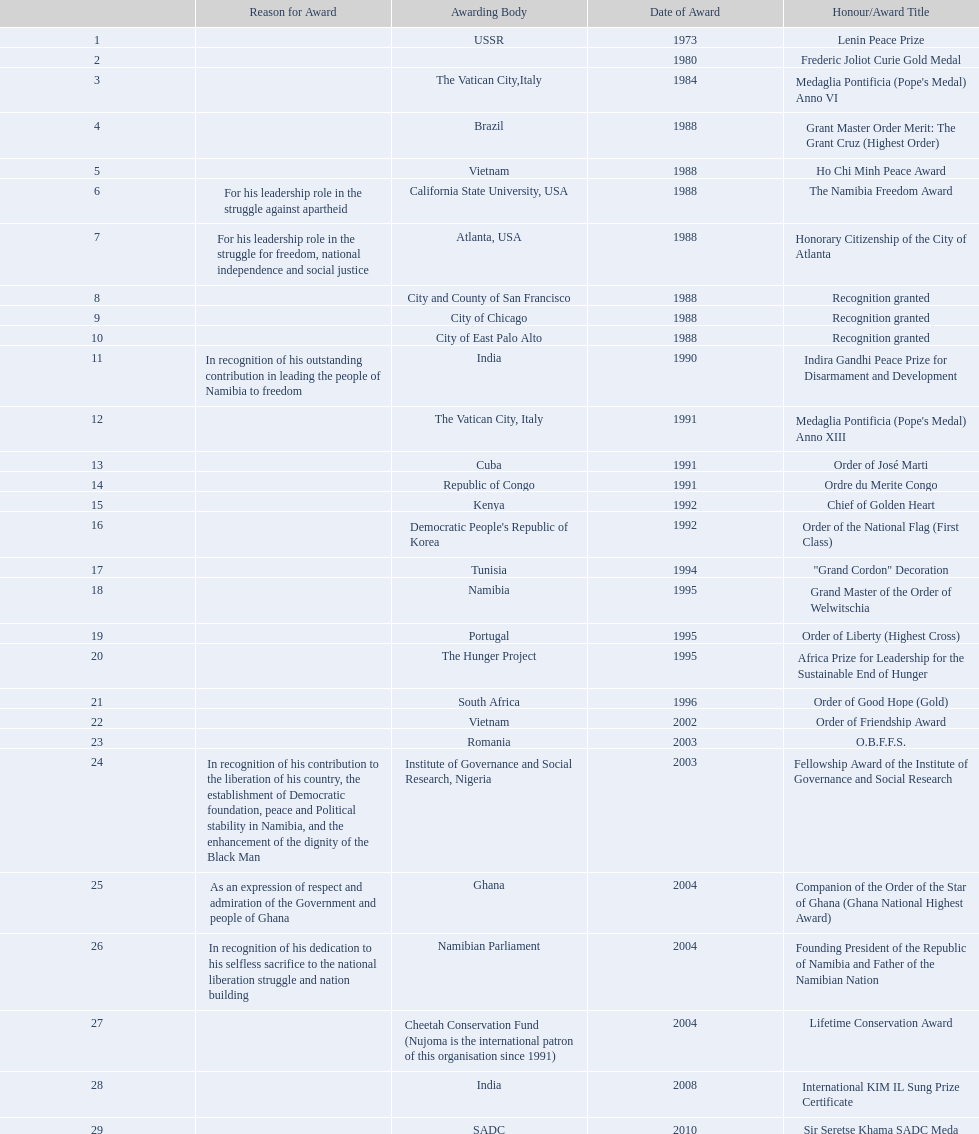What awards has sam nujoma been awarded? Lenin Peace Prize, Frederic Joliot Curie Gold Medal, Medaglia Pontificia (Pope's Medal) Anno VI, Grant Master Order Merit: The Grant Cruz (Highest Order), Ho Chi Minh Peace Award, The Namibia Freedom Award, Honorary Citizenship of the City of Atlanta, Recognition granted, Recognition granted, Recognition granted, Indira Gandhi Peace Prize for Disarmament and Development, Medaglia Pontificia (Pope's Medal) Anno XIII, Order of José Marti, Ordre du Merite Congo, Chief of Golden Heart, Order of the National Flag (First Class), "Grand Cordon" Decoration, Grand Master of the Order of Welwitschia, Order of Liberty (Highest Cross), Africa Prize for Leadership for the Sustainable End of Hunger, Order of Good Hope (Gold), Order of Friendship Award, O.B.F.F.S., Fellowship Award of the Institute of Governance and Social Research, Companion of the Order of the Star of Ghana (Ghana National Highest Award), Founding President of the Republic of Namibia and Father of the Namibian Nation, Lifetime Conservation Award, International KIM IL Sung Prize Certificate, Sir Seretse Khama SADC Meda. By which awarding body did sam nujoma receive the o.b.f.f.s award? Romania. 